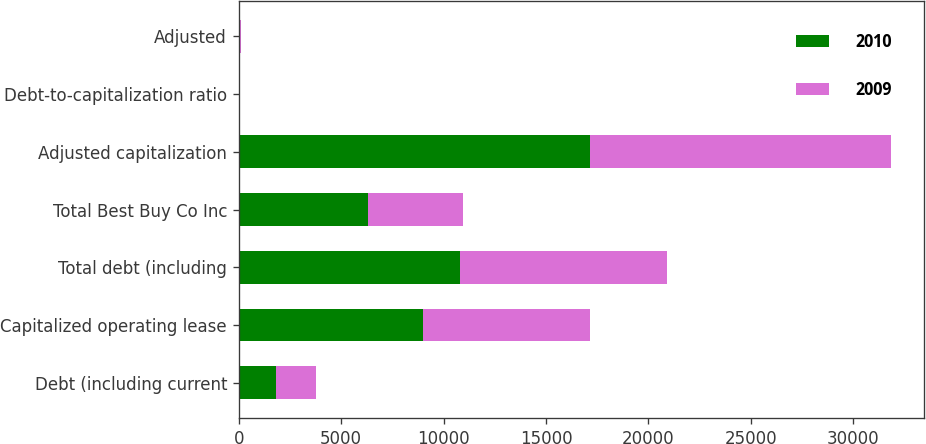Convert chart. <chart><loc_0><loc_0><loc_500><loc_500><stacked_bar_chart><ecel><fcel>Debt (including current<fcel>Capitalized operating lease<fcel>Total debt (including<fcel>Total Best Buy Co Inc<fcel>Adjusted capitalization<fcel>Debt-to-capitalization ratio<fcel>Adjusted<nl><fcel>2010<fcel>1802<fcel>9013<fcel>10815<fcel>6320<fcel>17135<fcel>22<fcel>63<nl><fcel>2009<fcel>1963<fcel>8114<fcel>10077<fcel>4643<fcel>14720<fcel>30<fcel>68<nl></chart> 